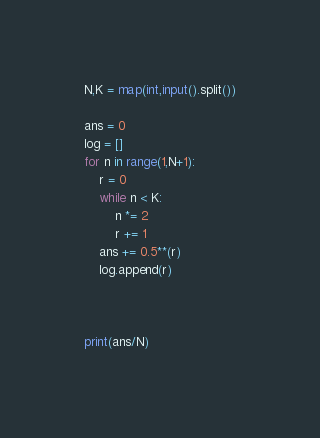Convert code to text. <code><loc_0><loc_0><loc_500><loc_500><_Python_>N,K = map(int,input().split())

ans = 0
log = []
for n in range(1,N+1):
    r = 0
    while n < K:
        n *= 2
        r += 1
    ans += 0.5**(r)
    log.append(r)

    

print(ans/N)</code> 